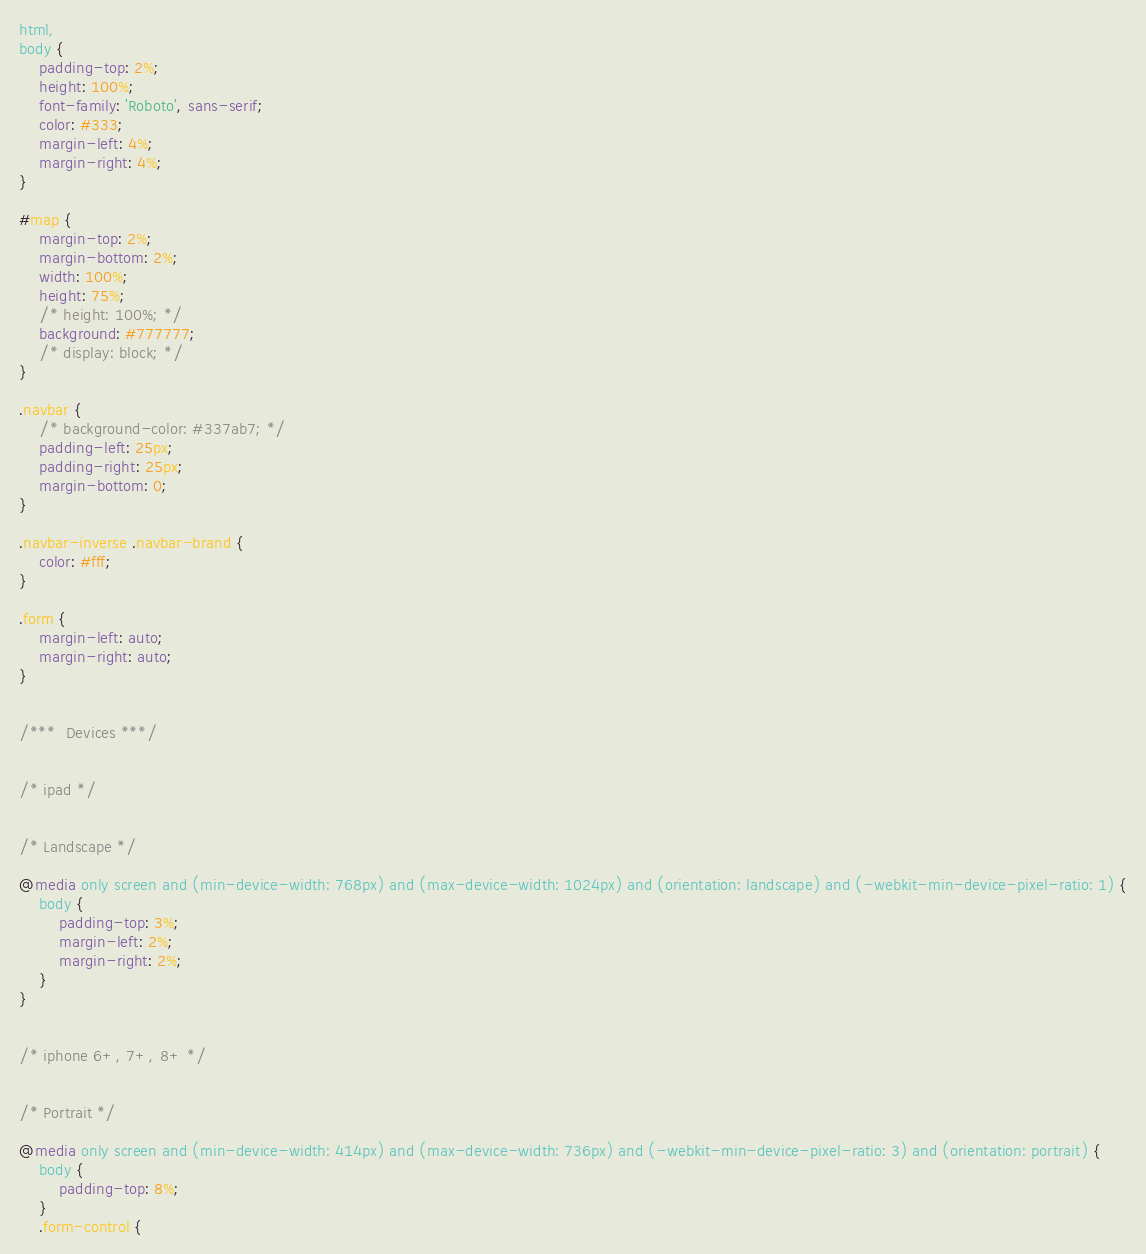Convert code to text. <code><loc_0><loc_0><loc_500><loc_500><_CSS_>html,
body {
    padding-top: 2%;
    height: 100%;
    font-family: 'Roboto', sans-serif;
    color: #333;
    margin-left: 4%;
    margin-right: 4%;
}

#map {
    margin-top: 2%;
    margin-bottom: 2%;
    width: 100%;
    height: 75%;
    /* height: 100%; */
    background: #777777;
    /* display: block; */
}

.navbar {
    /* background-color: #337ab7; */
    padding-left: 25px;
    padding-right: 25px;
    margin-bottom: 0;
}

.navbar-inverse .navbar-brand {
    color: #fff;
}

.form {
    margin-left: auto;
    margin-right: auto;
}


/***  Devices ***/


/* ipad */


/* Landscape */

@media only screen and (min-device-width: 768px) and (max-device-width: 1024px) and (orientation: landscape) and (-webkit-min-device-pixel-ratio: 1) {
    body {
        padding-top: 3%;
        margin-left: 2%;
        margin-right: 2%;
    }
}


/* iphone 6+, 7+, 8+ */


/* Portrait */

@media only screen and (min-device-width: 414px) and (max-device-width: 736px) and (-webkit-min-device-pixel-ratio: 3) and (orientation: portrait) {
    body {
        padding-top: 8%;
    }
    .form-control {</code> 